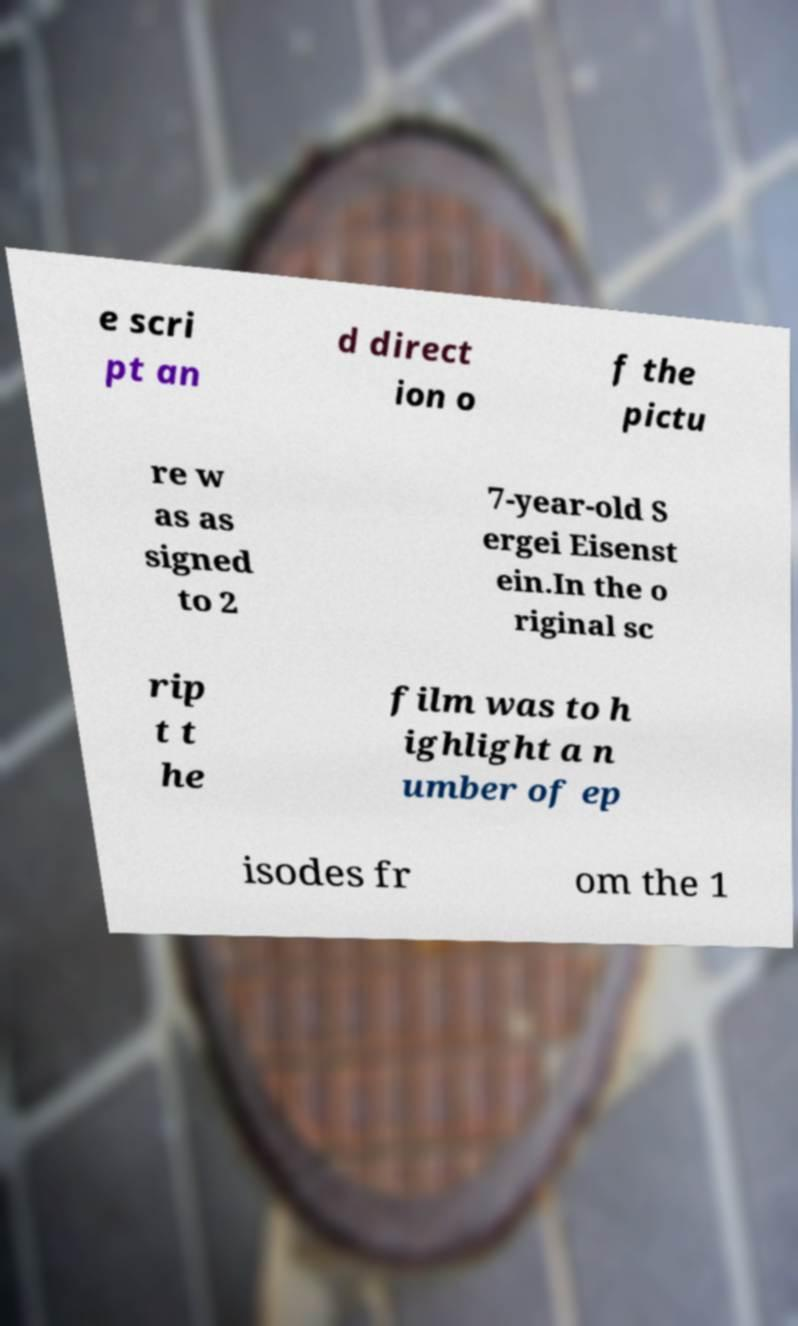Can you accurately transcribe the text from the provided image for me? e scri pt an d direct ion o f the pictu re w as as signed to 2 7-year-old S ergei Eisenst ein.In the o riginal sc rip t t he film was to h ighlight a n umber of ep isodes fr om the 1 